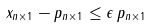Convert formula to latex. <formula><loc_0><loc_0><loc_500><loc_500>\| x _ { n \times 1 } - p _ { n \times 1 } \| \leq \epsilon \, \| p _ { n \times 1 } \|</formula> 